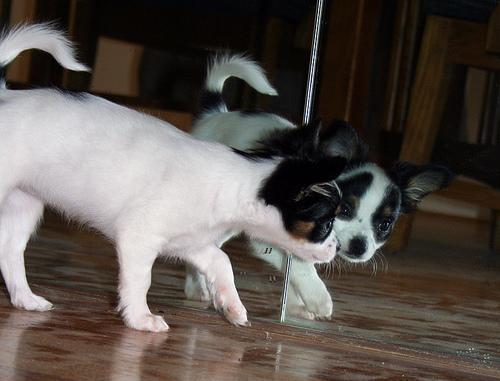How many puppies are looking in the mirror?
Give a very brief answer. 1. 